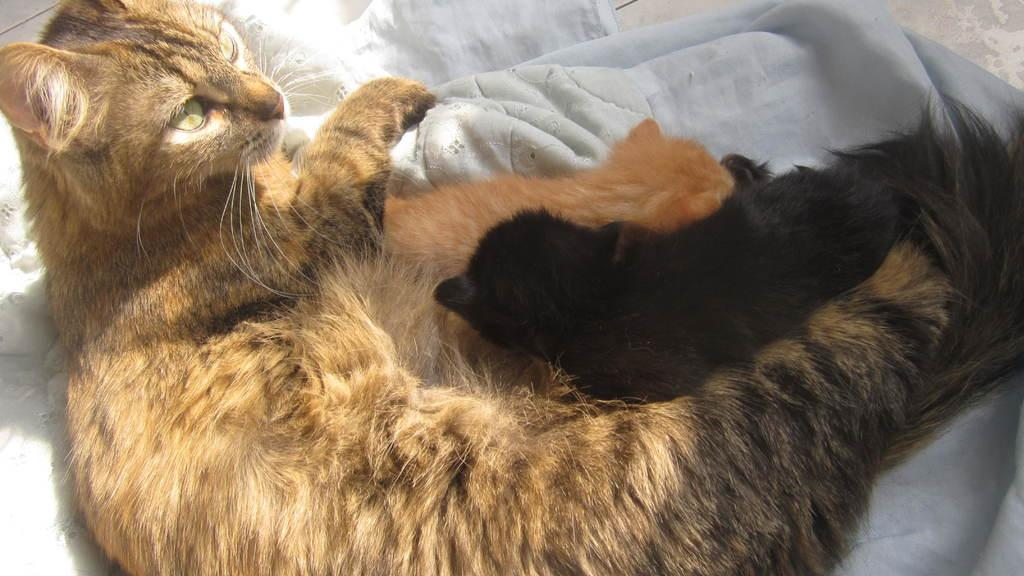How many cats are present in the image? There are two cats in the image. What is the color of the cloth on which the cats are sitting? The cats are on a white color cloth. What type of zephyr can be seen in the image? There is no zephyr present in the image; it is a picture of two cats on a white cloth. How does the beginner cat learn to jump in the image? There is no indication in the image that the cats are learning to jump or that they are beginners; they are simply sitting on a white cloth. 